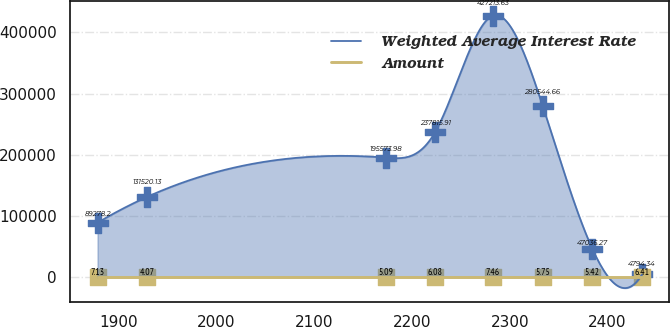<chart> <loc_0><loc_0><loc_500><loc_500><line_chart><ecel><fcel>Weighted Average Interest Rate<fcel>Amount<nl><fcel>1878.49<fcel>89278.2<fcel>7.13<nl><fcel>1929.29<fcel>131520<fcel>4.07<nl><fcel>2173.14<fcel>195574<fcel>5.09<nl><fcel>2223.93<fcel>237816<fcel>6.08<nl><fcel>2282.75<fcel>427214<fcel>7.46<nl><fcel>2333.55<fcel>280545<fcel>5.75<nl><fcel>2384.35<fcel>47036.3<fcel>5.42<nl><fcel>2435.14<fcel>4794.34<fcel>6.41<nl></chart> 